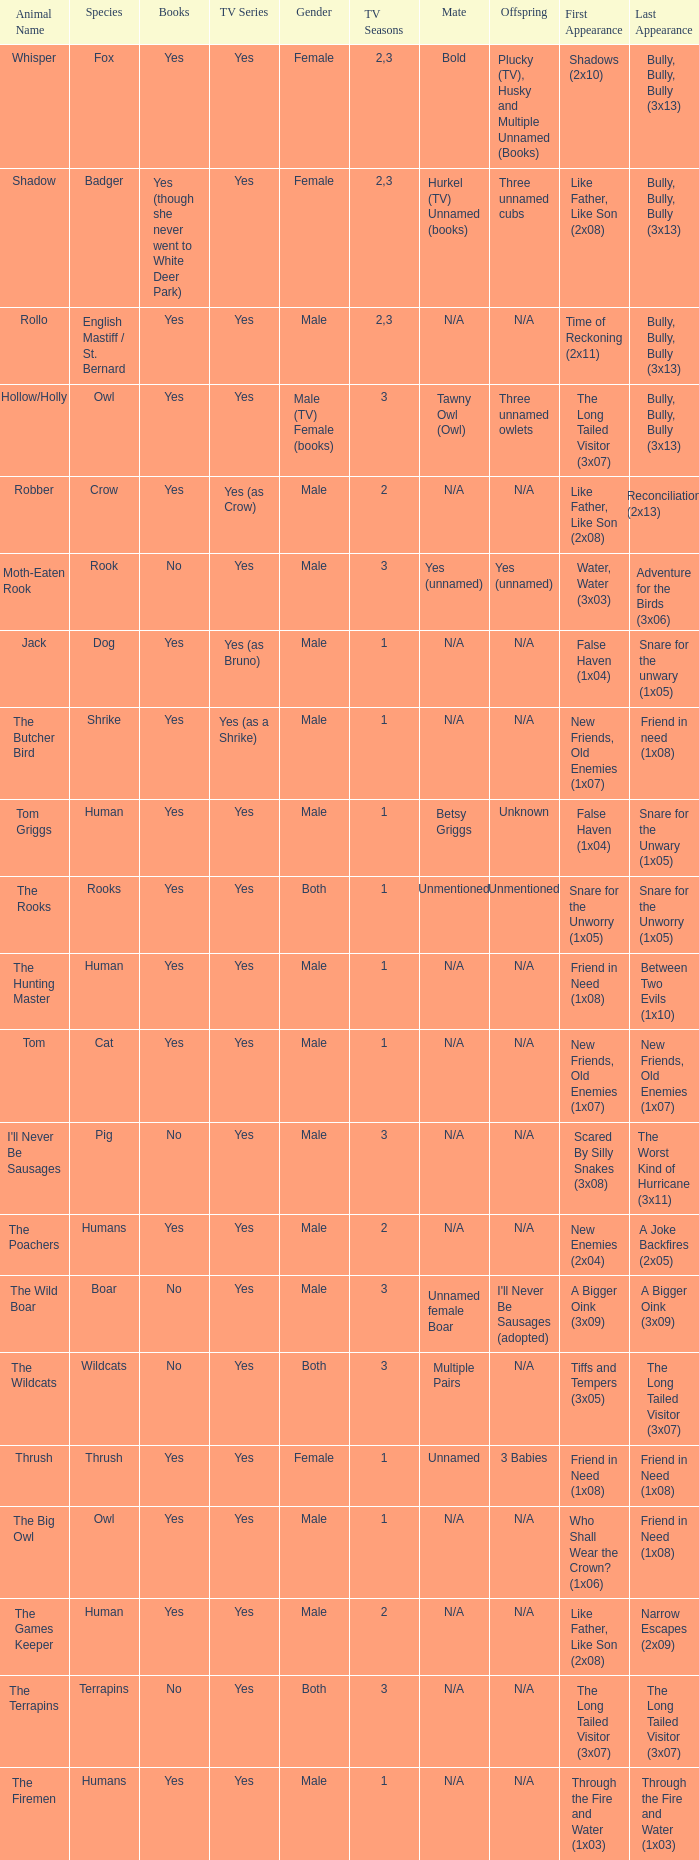What presentation contains a boar? Yes. 